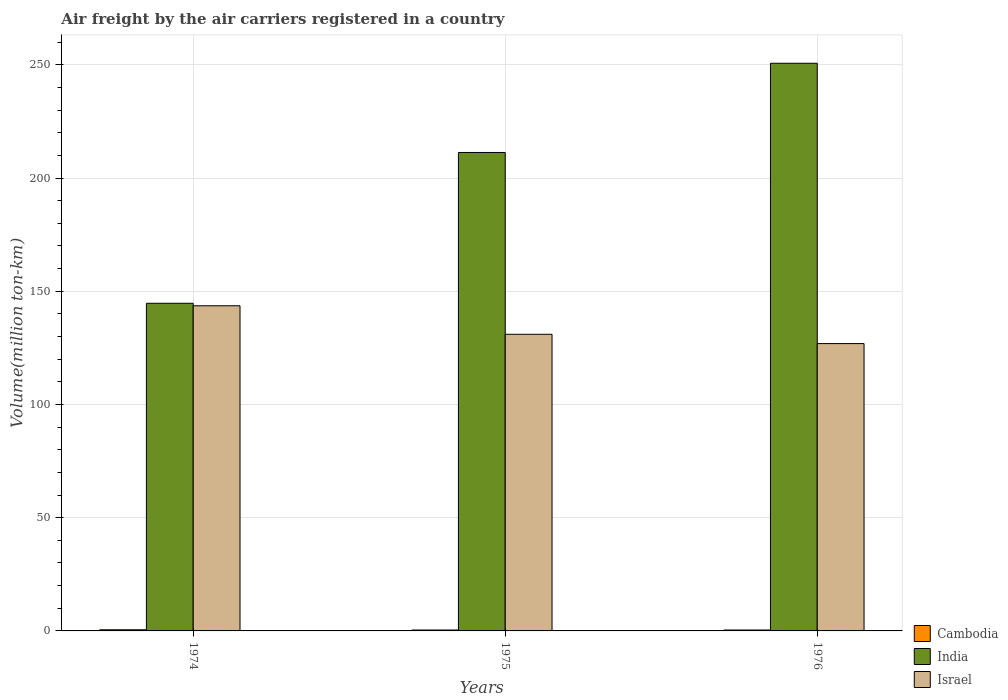How many different coloured bars are there?
Ensure brevity in your answer.  3. How many groups of bars are there?
Your response must be concise. 3. How many bars are there on the 2nd tick from the right?
Provide a short and direct response. 3. What is the label of the 3rd group of bars from the left?
Your answer should be very brief. 1976. Across all years, what is the maximum volume of the air carriers in India?
Give a very brief answer. 250.7. Across all years, what is the minimum volume of the air carriers in India?
Your response must be concise. 144.7. In which year was the volume of the air carriers in Israel maximum?
Ensure brevity in your answer.  1974. In which year was the volume of the air carriers in Cambodia minimum?
Your answer should be very brief. 1975. What is the total volume of the air carriers in India in the graph?
Your answer should be very brief. 606.7. What is the difference between the volume of the air carriers in Cambodia in 1975 and that in 1976?
Provide a short and direct response. 0. What is the difference between the volume of the air carriers in India in 1975 and the volume of the air carriers in Israel in 1974?
Offer a very short reply. 67.7. What is the average volume of the air carriers in Israel per year?
Offer a very short reply. 133.83. In the year 1976, what is the difference between the volume of the air carriers in India and volume of the air carriers in Cambodia?
Offer a terse response. 250.3. In how many years, is the volume of the air carriers in Israel greater than 90 million ton-km?
Your response must be concise. 3. What is the ratio of the volume of the air carriers in Israel in 1974 to that in 1976?
Make the answer very short. 1.13. Is the volume of the air carriers in India in 1974 less than that in 1976?
Offer a very short reply. Yes. Is the difference between the volume of the air carriers in India in 1974 and 1976 greater than the difference between the volume of the air carriers in Cambodia in 1974 and 1976?
Ensure brevity in your answer.  No. What is the difference between the highest and the second highest volume of the air carriers in Israel?
Offer a very short reply. 12.6. What is the difference between the highest and the lowest volume of the air carriers in Cambodia?
Your response must be concise. 0.1. Is the sum of the volume of the air carriers in India in 1974 and 1975 greater than the maximum volume of the air carriers in Israel across all years?
Your response must be concise. Yes. What is the difference between two consecutive major ticks on the Y-axis?
Your answer should be very brief. 50. Are the values on the major ticks of Y-axis written in scientific E-notation?
Provide a short and direct response. No. Does the graph contain any zero values?
Give a very brief answer. No. Does the graph contain grids?
Ensure brevity in your answer.  Yes. Where does the legend appear in the graph?
Offer a very short reply. Bottom right. How are the legend labels stacked?
Keep it short and to the point. Vertical. What is the title of the graph?
Your response must be concise. Air freight by the air carriers registered in a country. Does "Angola" appear as one of the legend labels in the graph?
Your answer should be very brief. No. What is the label or title of the Y-axis?
Your response must be concise. Volume(million ton-km). What is the Volume(million ton-km) in Cambodia in 1974?
Provide a short and direct response. 0.5. What is the Volume(million ton-km) in India in 1974?
Provide a short and direct response. 144.7. What is the Volume(million ton-km) in Israel in 1974?
Your answer should be very brief. 143.6. What is the Volume(million ton-km) of Cambodia in 1975?
Provide a short and direct response. 0.4. What is the Volume(million ton-km) in India in 1975?
Provide a succinct answer. 211.3. What is the Volume(million ton-km) of Israel in 1975?
Offer a very short reply. 131. What is the Volume(million ton-km) in Cambodia in 1976?
Provide a succinct answer. 0.4. What is the Volume(million ton-km) of India in 1976?
Give a very brief answer. 250.7. What is the Volume(million ton-km) of Israel in 1976?
Your response must be concise. 126.9. Across all years, what is the maximum Volume(million ton-km) of India?
Give a very brief answer. 250.7. Across all years, what is the maximum Volume(million ton-km) of Israel?
Give a very brief answer. 143.6. Across all years, what is the minimum Volume(million ton-km) in Cambodia?
Make the answer very short. 0.4. Across all years, what is the minimum Volume(million ton-km) in India?
Provide a succinct answer. 144.7. Across all years, what is the minimum Volume(million ton-km) in Israel?
Provide a succinct answer. 126.9. What is the total Volume(million ton-km) in India in the graph?
Your answer should be compact. 606.7. What is the total Volume(million ton-km) in Israel in the graph?
Give a very brief answer. 401.5. What is the difference between the Volume(million ton-km) in Cambodia in 1974 and that in 1975?
Your answer should be very brief. 0.1. What is the difference between the Volume(million ton-km) of India in 1974 and that in 1975?
Your answer should be compact. -66.6. What is the difference between the Volume(million ton-km) of India in 1974 and that in 1976?
Offer a terse response. -106. What is the difference between the Volume(million ton-km) of Israel in 1974 and that in 1976?
Make the answer very short. 16.7. What is the difference between the Volume(million ton-km) of India in 1975 and that in 1976?
Keep it short and to the point. -39.4. What is the difference between the Volume(million ton-km) in Cambodia in 1974 and the Volume(million ton-km) in India in 1975?
Provide a short and direct response. -210.8. What is the difference between the Volume(million ton-km) in Cambodia in 1974 and the Volume(million ton-km) in Israel in 1975?
Your response must be concise. -130.5. What is the difference between the Volume(million ton-km) of Cambodia in 1974 and the Volume(million ton-km) of India in 1976?
Your response must be concise. -250.2. What is the difference between the Volume(million ton-km) of Cambodia in 1974 and the Volume(million ton-km) of Israel in 1976?
Your answer should be compact. -126.4. What is the difference between the Volume(million ton-km) in India in 1974 and the Volume(million ton-km) in Israel in 1976?
Make the answer very short. 17.8. What is the difference between the Volume(million ton-km) in Cambodia in 1975 and the Volume(million ton-km) in India in 1976?
Your answer should be compact. -250.3. What is the difference between the Volume(million ton-km) in Cambodia in 1975 and the Volume(million ton-km) in Israel in 1976?
Offer a very short reply. -126.5. What is the difference between the Volume(million ton-km) in India in 1975 and the Volume(million ton-km) in Israel in 1976?
Provide a short and direct response. 84.4. What is the average Volume(million ton-km) in Cambodia per year?
Offer a terse response. 0.43. What is the average Volume(million ton-km) of India per year?
Your response must be concise. 202.23. What is the average Volume(million ton-km) of Israel per year?
Offer a terse response. 133.83. In the year 1974, what is the difference between the Volume(million ton-km) of Cambodia and Volume(million ton-km) of India?
Your answer should be compact. -144.2. In the year 1974, what is the difference between the Volume(million ton-km) of Cambodia and Volume(million ton-km) of Israel?
Offer a terse response. -143.1. In the year 1975, what is the difference between the Volume(million ton-km) in Cambodia and Volume(million ton-km) in India?
Offer a terse response. -210.9. In the year 1975, what is the difference between the Volume(million ton-km) of Cambodia and Volume(million ton-km) of Israel?
Provide a short and direct response. -130.6. In the year 1975, what is the difference between the Volume(million ton-km) in India and Volume(million ton-km) in Israel?
Provide a short and direct response. 80.3. In the year 1976, what is the difference between the Volume(million ton-km) of Cambodia and Volume(million ton-km) of India?
Provide a succinct answer. -250.3. In the year 1976, what is the difference between the Volume(million ton-km) in Cambodia and Volume(million ton-km) in Israel?
Make the answer very short. -126.5. In the year 1976, what is the difference between the Volume(million ton-km) of India and Volume(million ton-km) of Israel?
Keep it short and to the point. 123.8. What is the ratio of the Volume(million ton-km) in Cambodia in 1974 to that in 1975?
Provide a succinct answer. 1.25. What is the ratio of the Volume(million ton-km) in India in 1974 to that in 1975?
Give a very brief answer. 0.68. What is the ratio of the Volume(million ton-km) in Israel in 1974 to that in 1975?
Your answer should be very brief. 1.1. What is the ratio of the Volume(million ton-km) of India in 1974 to that in 1976?
Offer a very short reply. 0.58. What is the ratio of the Volume(million ton-km) in Israel in 1974 to that in 1976?
Keep it short and to the point. 1.13. What is the ratio of the Volume(million ton-km) of Cambodia in 1975 to that in 1976?
Provide a short and direct response. 1. What is the ratio of the Volume(million ton-km) in India in 1975 to that in 1976?
Provide a short and direct response. 0.84. What is the ratio of the Volume(million ton-km) in Israel in 1975 to that in 1976?
Your answer should be compact. 1.03. What is the difference between the highest and the second highest Volume(million ton-km) of India?
Provide a short and direct response. 39.4. What is the difference between the highest and the lowest Volume(million ton-km) in Cambodia?
Ensure brevity in your answer.  0.1. What is the difference between the highest and the lowest Volume(million ton-km) in India?
Offer a very short reply. 106. What is the difference between the highest and the lowest Volume(million ton-km) in Israel?
Offer a very short reply. 16.7. 